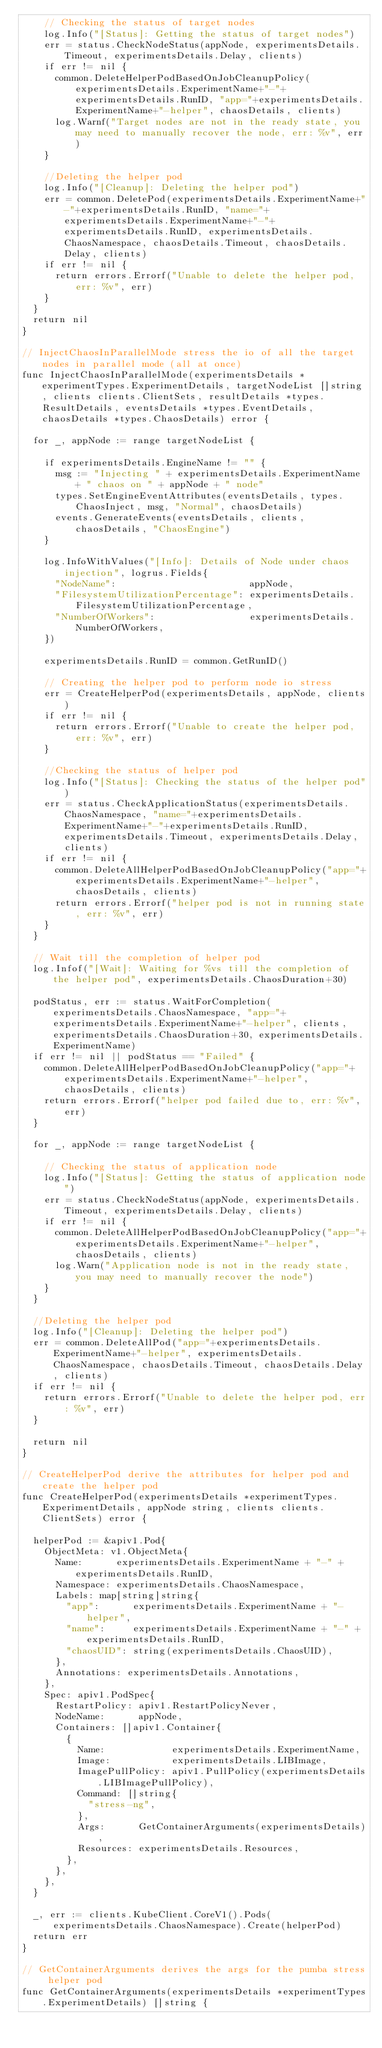Convert code to text. <code><loc_0><loc_0><loc_500><loc_500><_Go_>		// Checking the status of target nodes
		log.Info("[Status]: Getting the status of target nodes")
		err = status.CheckNodeStatus(appNode, experimentsDetails.Timeout, experimentsDetails.Delay, clients)
		if err != nil {
			common.DeleteHelperPodBasedOnJobCleanupPolicy(experimentsDetails.ExperimentName+"-"+experimentsDetails.RunID, "app="+experimentsDetails.ExperimentName+"-helper", chaosDetails, clients)
			log.Warnf("Target nodes are not in the ready state, you may need to manually recover the node, err: %v", err)
		}

		//Deleting the helper pod
		log.Info("[Cleanup]: Deleting the helper pod")
		err = common.DeletePod(experimentsDetails.ExperimentName+"-"+experimentsDetails.RunID, "name="+experimentsDetails.ExperimentName+"-"+experimentsDetails.RunID, experimentsDetails.ChaosNamespace, chaosDetails.Timeout, chaosDetails.Delay, clients)
		if err != nil {
			return errors.Errorf("Unable to delete the helper pod, err: %v", err)
		}
	}
	return nil
}

// InjectChaosInParallelMode stress the io of all the target nodes in parallel mode (all at once)
func InjectChaosInParallelMode(experimentsDetails *experimentTypes.ExperimentDetails, targetNodeList []string, clients clients.ClientSets, resultDetails *types.ResultDetails, eventsDetails *types.EventDetails, chaosDetails *types.ChaosDetails) error {

	for _, appNode := range targetNodeList {

		if experimentsDetails.EngineName != "" {
			msg := "Injecting " + experimentsDetails.ExperimentName + " chaos on " + appNode + " node"
			types.SetEngineEventAttributes(eventsDetails, types.ChaosInject, msg, "Normal", chaosDetails)
			events.GenerateEvents(eventsDetails, clients, chaosDetails, "ChaosEngine")
		}

		log.InfoWithValues("[Info]: Details of Node under chaos injection", logrus.Fields{
			"NodeName":                        appNode,
			"FilesystemUtilizationPercentage": experimentsDetails.FilesystemUtilizationPercentage,
			"NumberOfWorkers":                 experimentsDetails.NumberOfWorkers,
		})

		experimentsDetails.RunID = common.GetRunID()

		// Creating the helper pod to perform node io stress
		err = CreateHelperPod(experimentsDetails, appNode, clients)
		if err != nil {
			return errors.Errorf("Unable to create the helper pod, err: %v", err)
		}

		//Checking the status of helper pod
		log.Info("[Status]: Checking the status of the helper pod")
		err = status.CheckApplicationStatus(experimentsDetails.ChaosNamespace, "name="+experimentsDetails.ExperimentName+"-"+experimentsDetails.RunID, experimentsDetails.Timeout, experimentsDetails.Delay, clients)
		if err != nil {
			common.DeleteAllHelperPodBasedOnJobCleanupPolicy("app="+experimentsDetails.ExperimentName+"-helper", chaosDetails, clients)
			return errors.Errorf("helper pod is not in running state, err: %v", err)
		}
	}

	// Wait till the completion of helper pod
	log.Infof("[Wait]: Waiting for %vs till the completion of the helper pod", experimentsDetails.ChaosDuration+30)

	podStatus, err := status.WaitForCompletion(experimentsDetails.ChaosNamespace, "app="+experimentsDetails.ExperimentName+"-helper", clients, experimentsDetails.ChaosDuration+30, experimentsDetails.ExperimentName)
	if err != nil || podStatus == "Failed" {
		common.DeleteAllHelperPodBasedOnJobCleanupPolicy("app="+experimentsDetails.ExperimentName+"-helper", chaosDetails, clients)
		return errors.Errorf("helper pod failed due to, err: %v", err)
	}

	for _, appNode := range targetNodeList {

		// Checking the status of application node
		log.Info("[Status]: Getting the status of application node")
		err = status.CheckNodeStatus(appNode, experimentsDetails.Timeout, experimentsDetails.Delay, clients)
		if err != nil {
			common.DeleteAllHelperPodBasedOnJobCleanupPolicy("app="+experimentsDetails.ExperimentName+"-helper", chaosDetails, clients)
			log.Warn("Application node is not in the ready state, you may need to manually recover the node")
		}
	}

	//Deleting the helper pod
	log.Info("[Cleanup]: Deleting the helper pod")
	err = common.DeleteAllPod("app="+experimentsDetails.ExperimentName+"-helper", experimentsDetails.ChaosNamespace, chaosDetails.Timeout, chaosDetails.Delay, clients)
	if err != nil {
		return errors.Errorf("Unable to delete the helper pod, err: %v", err)
	}

	return nil
}

// CreateHelperPod derive the attributes for helper pod and create the helper pod
func CreateHelperPod(experimentsDetails *experimentTypes.ExperimentDetails, appNode string, clients clients.ClientSets) error {

	helperPod := &apiv1.Pod{
		ObjectMeta: v1.ObjectMeta{
			Name:      experimentsDetails.ExperimentName + "-" + experimentsDetails.RunID,
			Namespace: experimentsDetails.ChaosNamespace,
			Labels: map[string]string{
				"app":      experimentsDetails.ExperimentName + "-helper",
				"name":     experimentsDetails.ExperimentName + "-" + experimentsDetails.RunID,
				"chaosUID": string(experimentsDetails.ChaosUID),
			},
			Annotations: experimentsDetails.Annotations,
		},
		Spec: apiv1.PodSpec{
			RestartPolicy: apiv1.RestartPolicyNever,
			NodeName:      appNode,
			Containers: []apiv1.Container{
				{
					Name:            experimentsDetails.ExperimentName,
					Image:           experimentsDetails.LIBImage,
					ImagePullPolicy: apiv1.PullPolicy(experimentsDetails.LIBImagePullPolicy),
					Command: []string{
						"stress-ng",
					},
					Args:      GetContainerArguments(experimentsDetails),
					Resources: experimentsDetails.Resources,
				},
			},
		},
	}

	_, err := clients.KubeClient.CoreV1().Pods(experimentsDetails.ChaosNamespace).Create(helperPod)
	return err
}

// GetContainerArguments derives the args for the pumba stress helper pod
func GetContainerArguments(experimentsDetails *experimentTypes.ExperimentDetails) []string {
</code> 